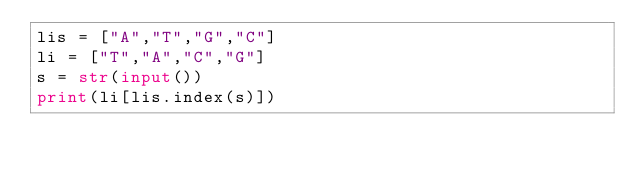<code> <loc_0><loc_0><loc_500><loc_500><_Python_>lis = ["A","T","G","C"]
li = ["T","A","C","G"]
s = str(input())
print(li[lis.index(s)])</code> 